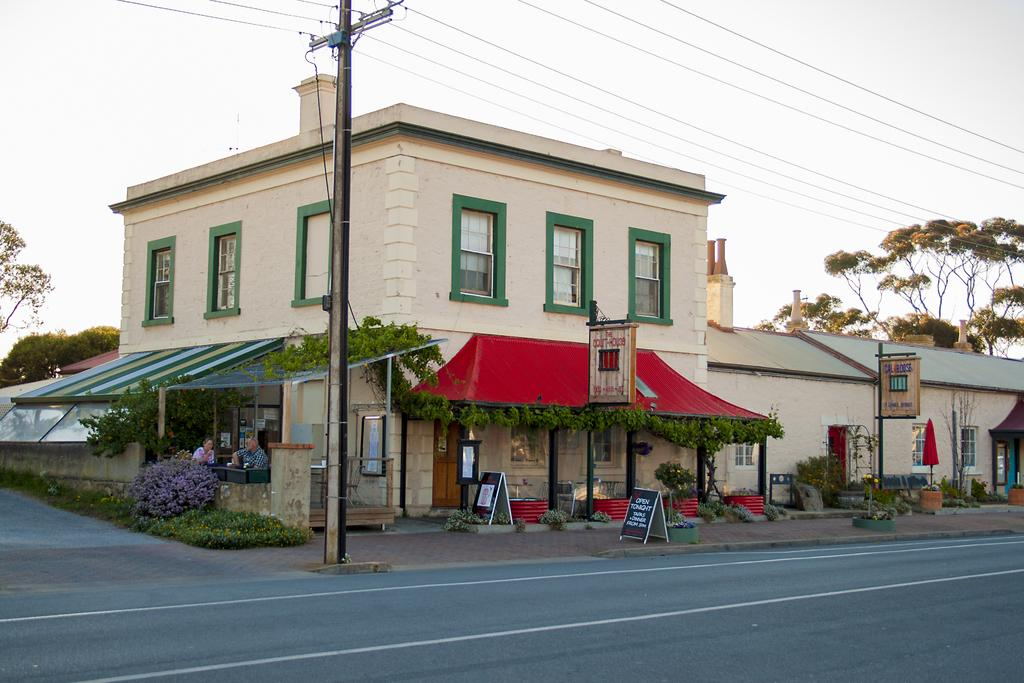What is located at the bottom of the image? There is a road at the bottom of the image. What structure is in the center of the image? There is a house in the center of the image. What type of vegetation can be seen in the image? There are plants in the image. What object is present in the image that might be used for supporting or holding something? There is a pole in the image. What can be seen in the background of the image? There are trees and the sky visible in the background of the image. Where is the bedroom located in the image? There is no bedroom present in the image. What type of connection can be seen between the house and the road in the image? There is no visible connection between the house and the road in the image. 